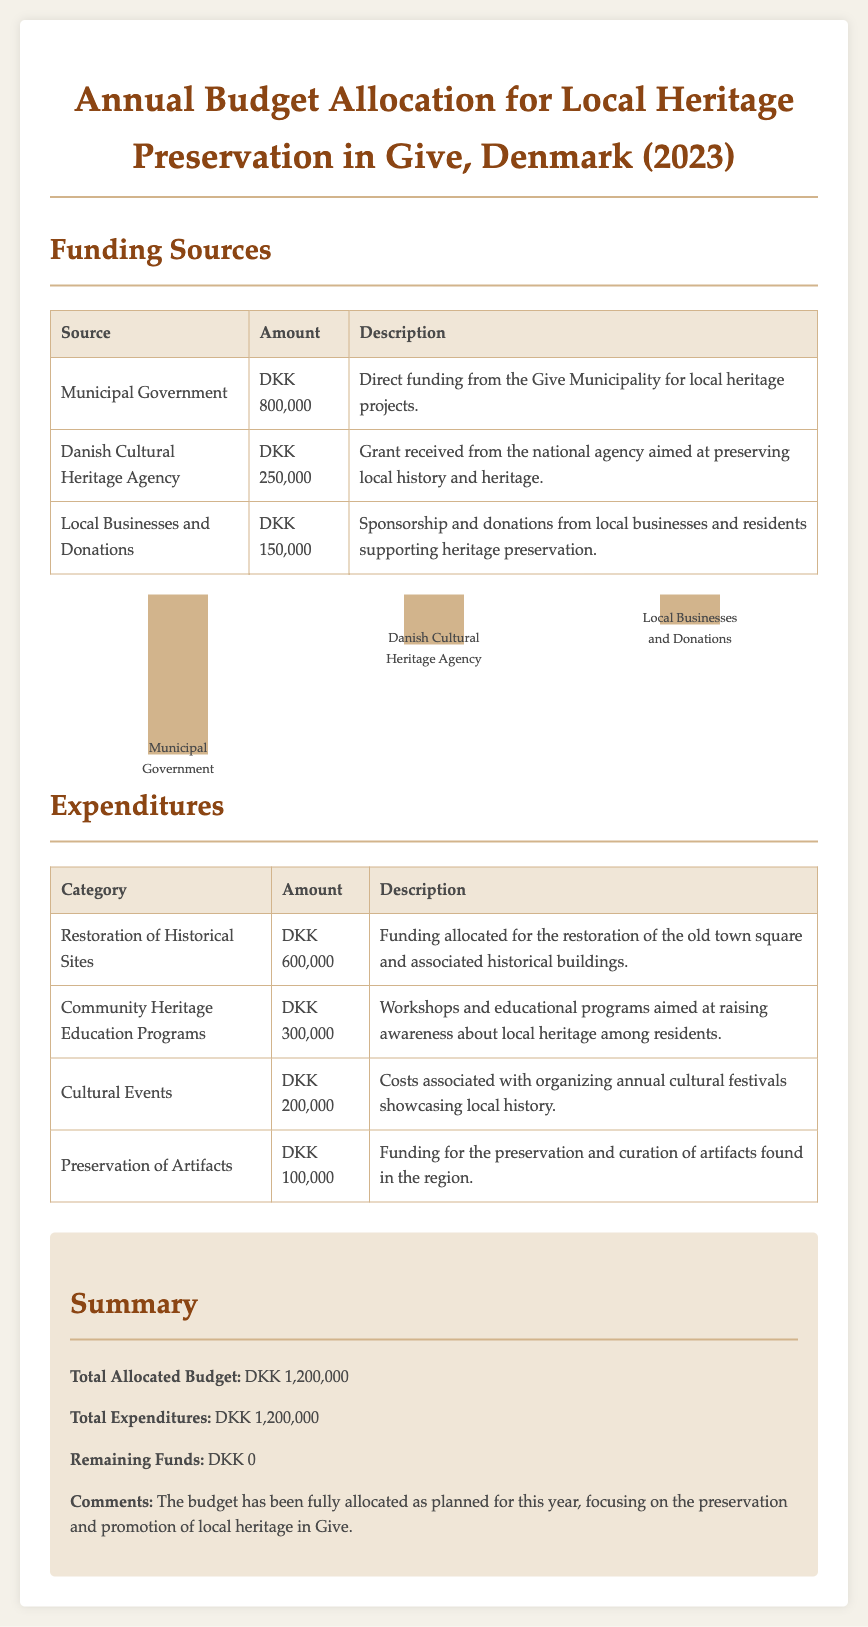What is the total allocated budget? The total allocated budget is stated in the summary section of the document as DKK 1,200,000.
Answer: DKK 1,200,000 How much funding comes from local businesses and donations? The funding from local businesses and donations is listed in the funding sources table as DKK 150,000.
Answer: DKK 150,000 What is the expenditure for the restoration of historical sites? The expenditure for the restoration of historical sites is detailed in the expenditures table as DKK 600,000.
Answer: DKK 600,000 Which organization provided DKK 250,000 for heritage initiatives? The funding source providing DKK 250,000 is specified in the document as the Danish Cultural Heritage Agency.
Answer: Danish Cultural Heritage Agency What is the total amount allocated for cultural events? The total amount for cultural events is indicated in the expenditures table as DKK 200,000.
Answer: DKK 200,000 How much was spent on community heritage education programs? The amount spent on community heritage education programs is listed in the expenditures section as DKK 300,000.
Answer: DKK 300,000 What is the remaining funds after expenditures? The remaining funds after expenditures is noted in the summary section as DKK 0.
Answer: DKK 0 What is the purpose of the funding from the municipal government? The municipal government funding is described in the document as direct funding for local heritage projects.
Answer: Direct funding for local heritage projects What is the total amount allocated for preserving artifacts? The total allocated for preserving artifacts is shown in the expenditures table as DKK 100,000.
Answer: DKK 100,000 